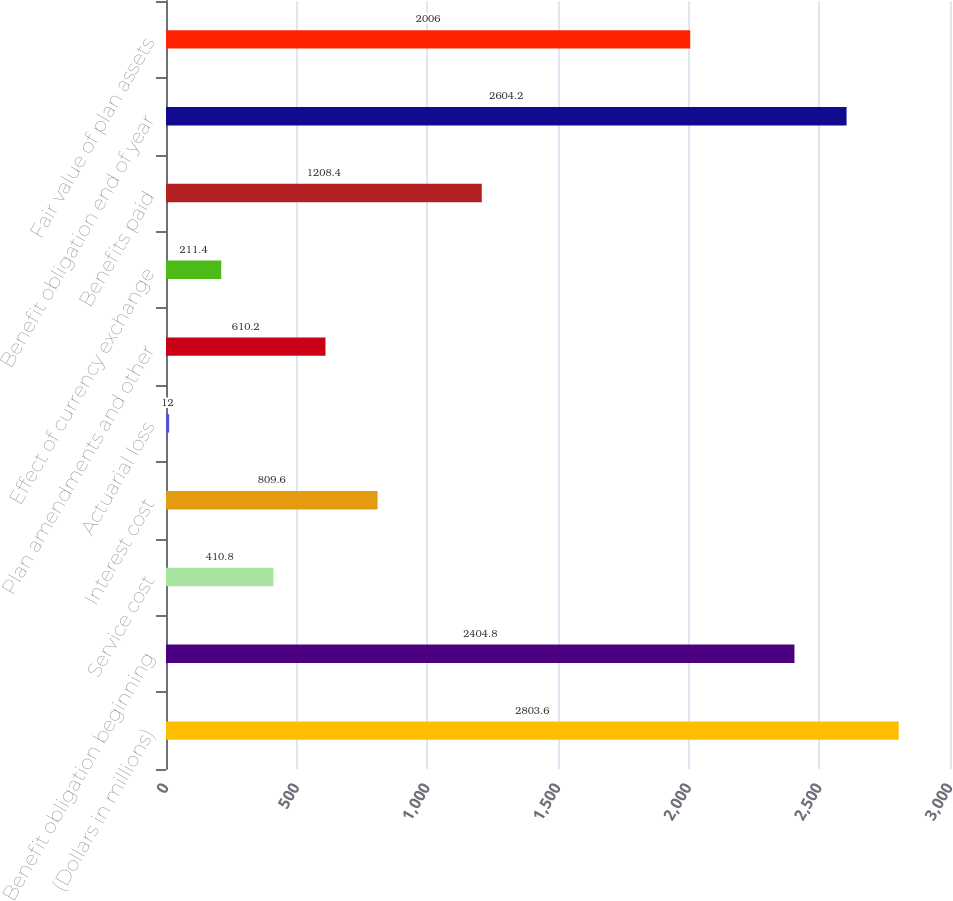Convert chart. <chart><loc_0><loc_0><loc_500><loc_500><bar_chart><fcel>(Dollars in millions)<fcel>Benefit obligation beginning<fcel>Service cost<fcel>Interest cost<fcel>Actuarial loss<fcel>Plan amendments and other<fcel>Effect of currency exchange<fcel>Benefits paid<fcel>Benefit obligation end of year<fcel>Fair value of plan assets<nl><fcel>2803.6<fcel>2404.8<fcel>410.8<fcel>809.6<fcel>12<fcel>610.2<fcel>211.4<fcel>1208.4<fcel>2604.2<fcel>2006<nl></chart> 